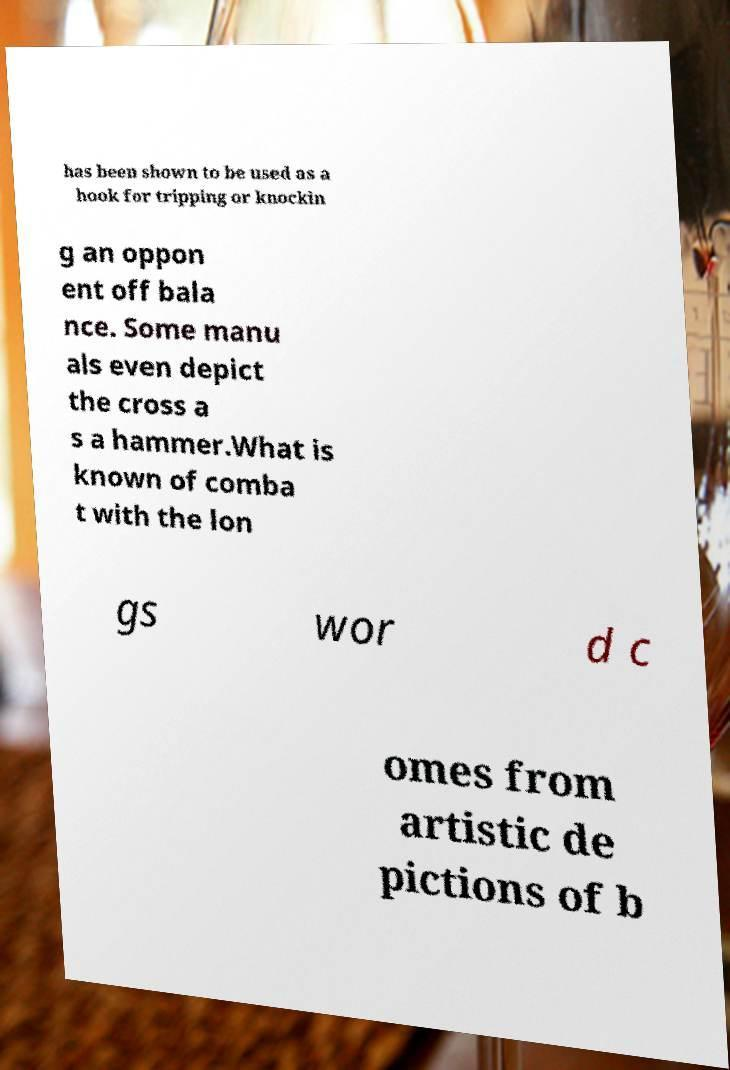Could you assist in decoding the text presented in this image and type it out clearly? has been shown to be used as a hook for tripping or knockin g an oppon ent off bala nce. Some manu als even depict the cross a s a hammer.What is known of comba t with the lon gs wor d c omes from artistic de pictions of b 